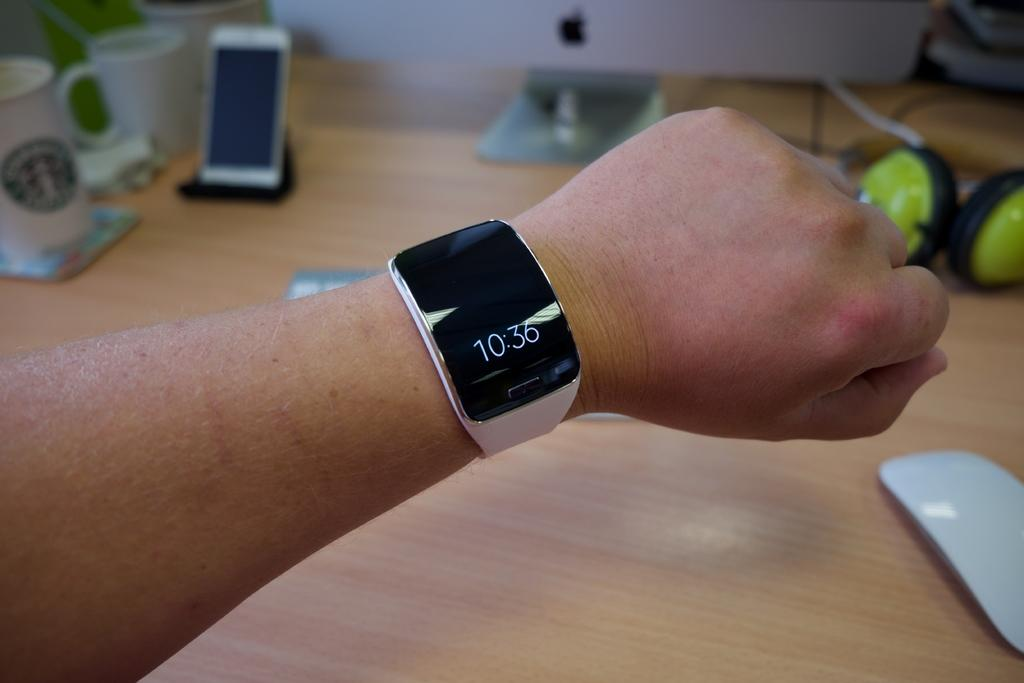<image>
Describe the image concisely. A watch, bearing the time of 10:36, is on someone's arm. 